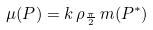<formula> <loc_0><loc_0><loc_500><loc_500>\mu ( P ) = k \, \rho _ { \frac { \pi } { 2 } } \, m ( P ^ { * } )</formula> 